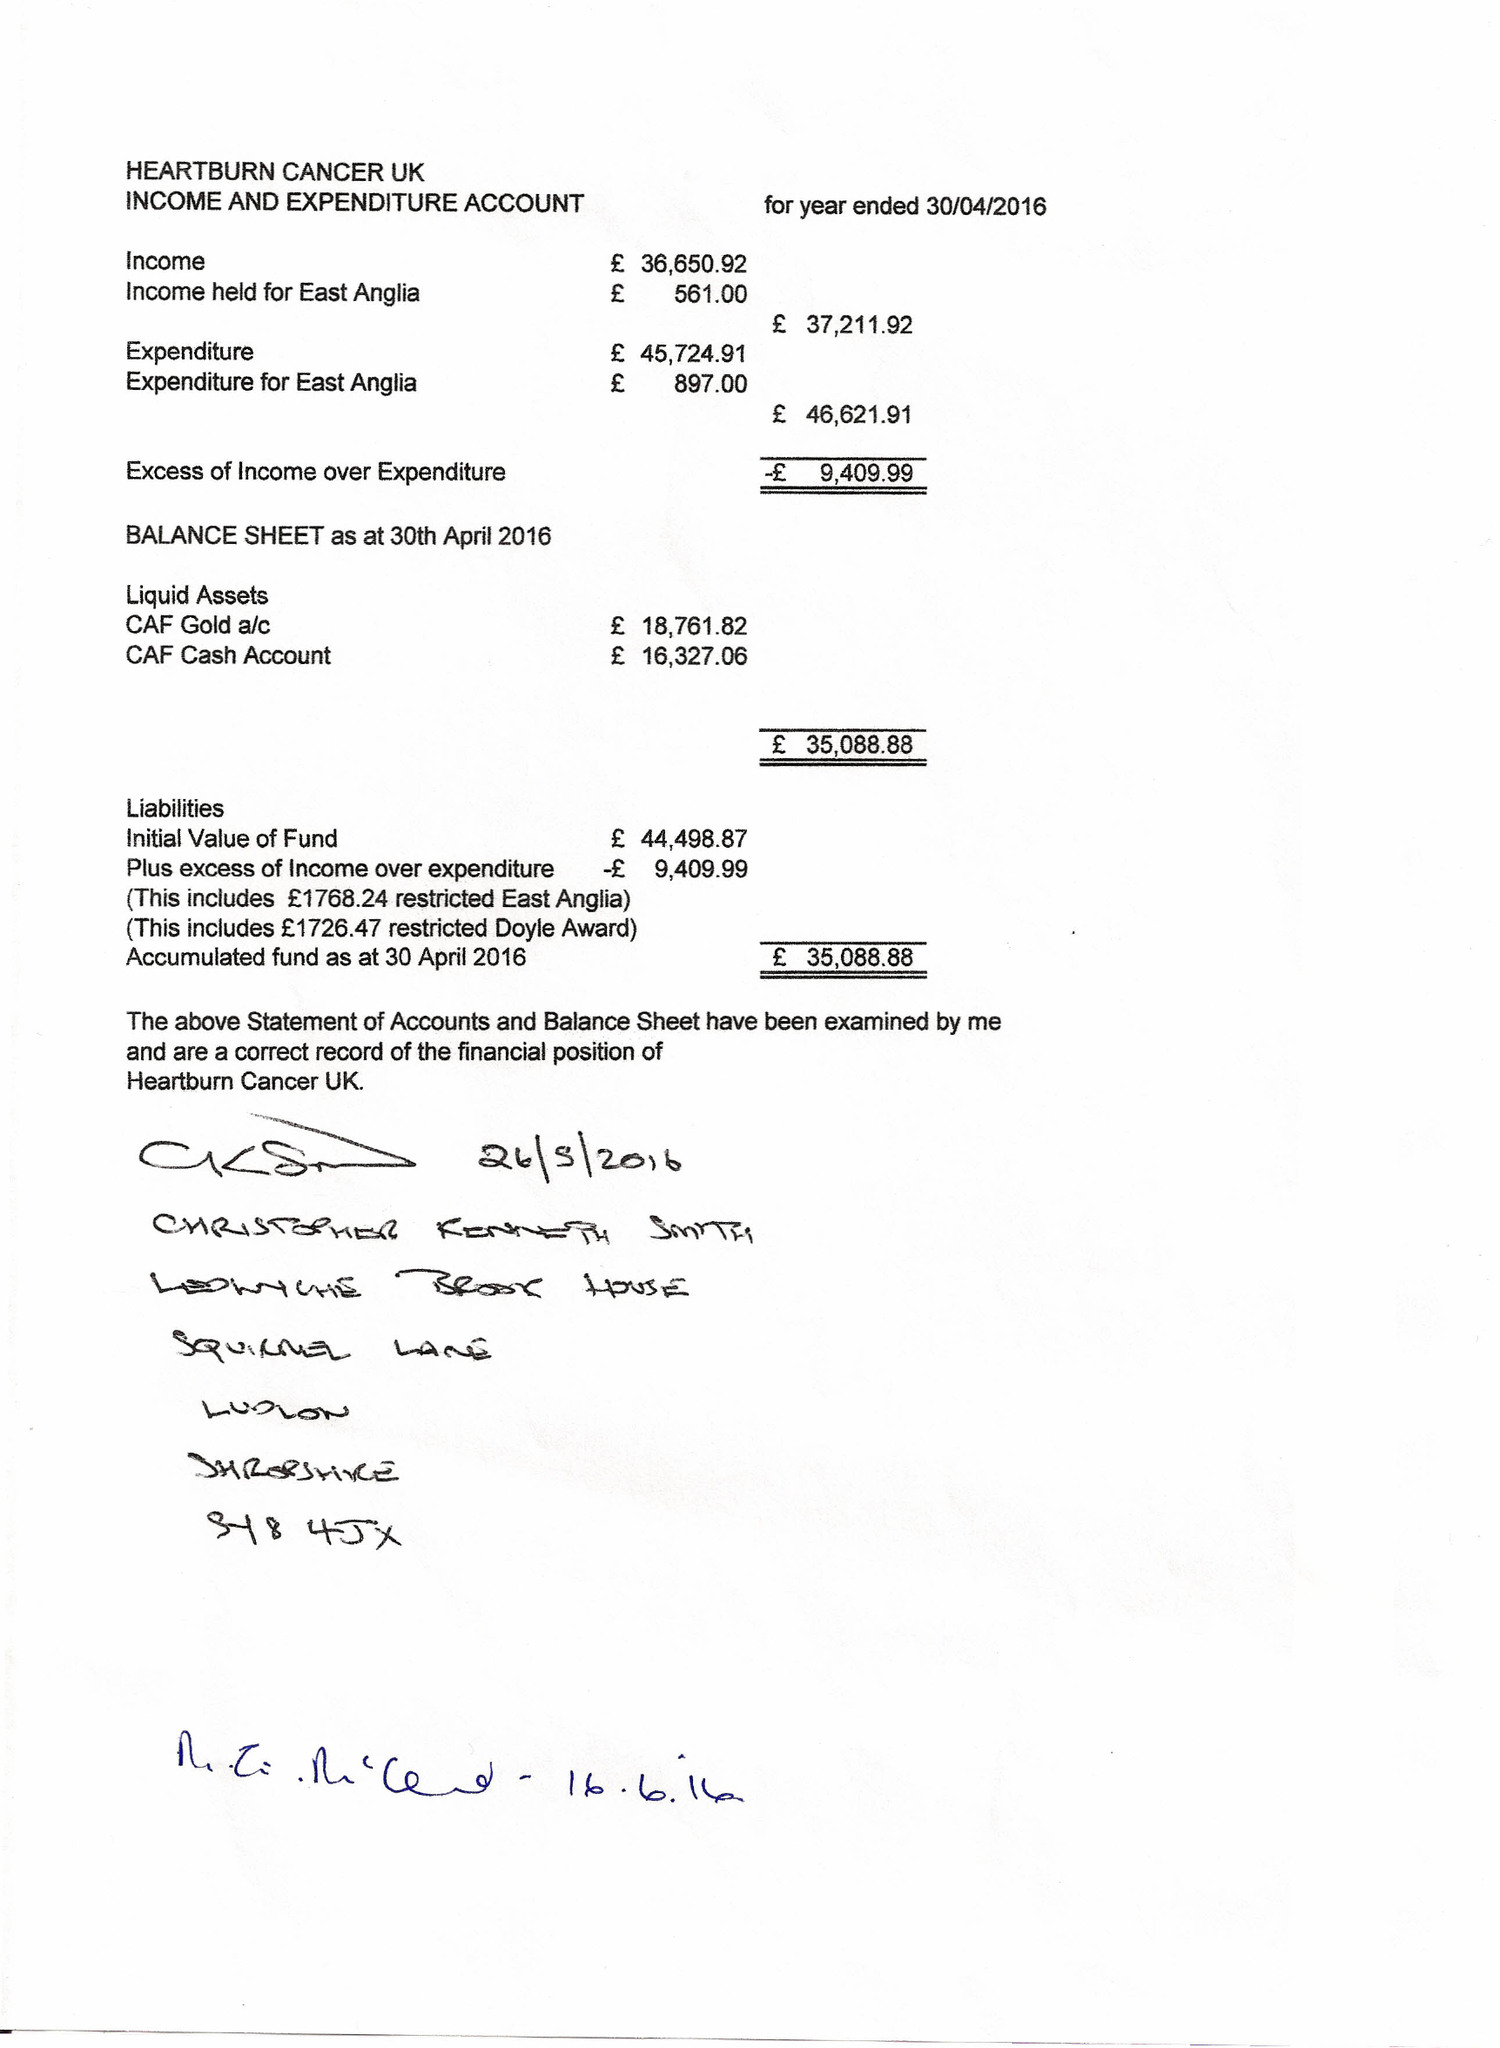What is the value for the address__post_town?
Answer the question using a single word or phrase. CHICHESTER 